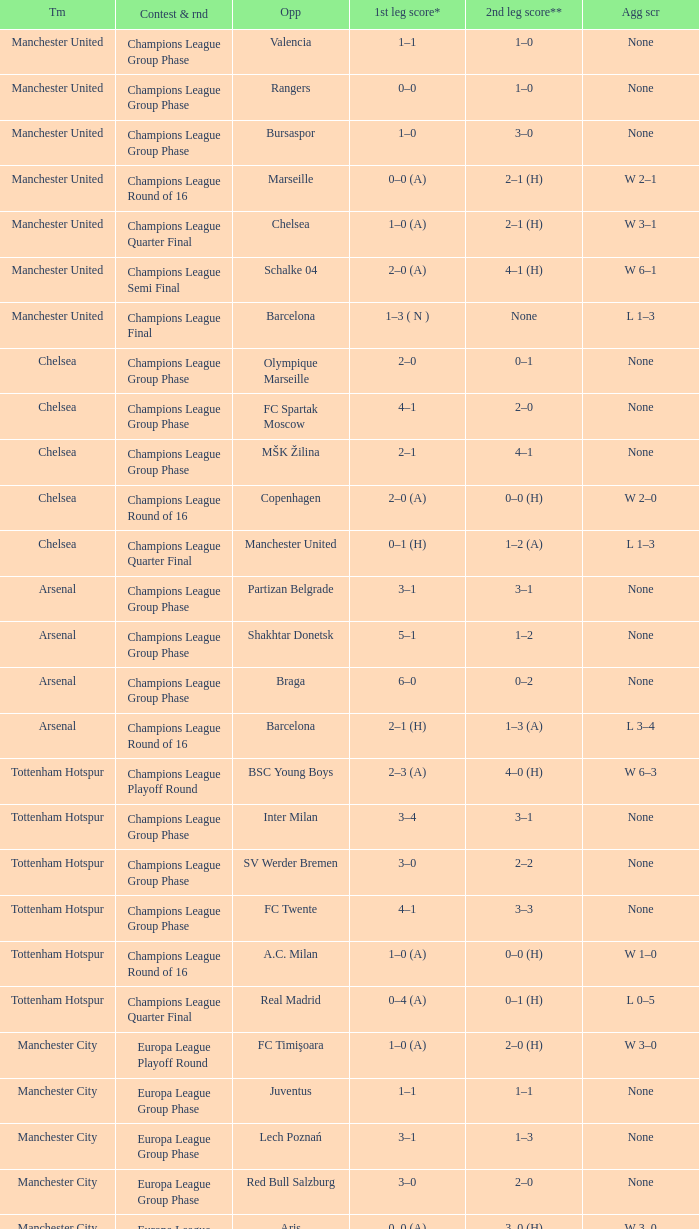How many goals did each team score in the first leg of the match between Liverpool and Steaua Bucureşti? 4–1. 